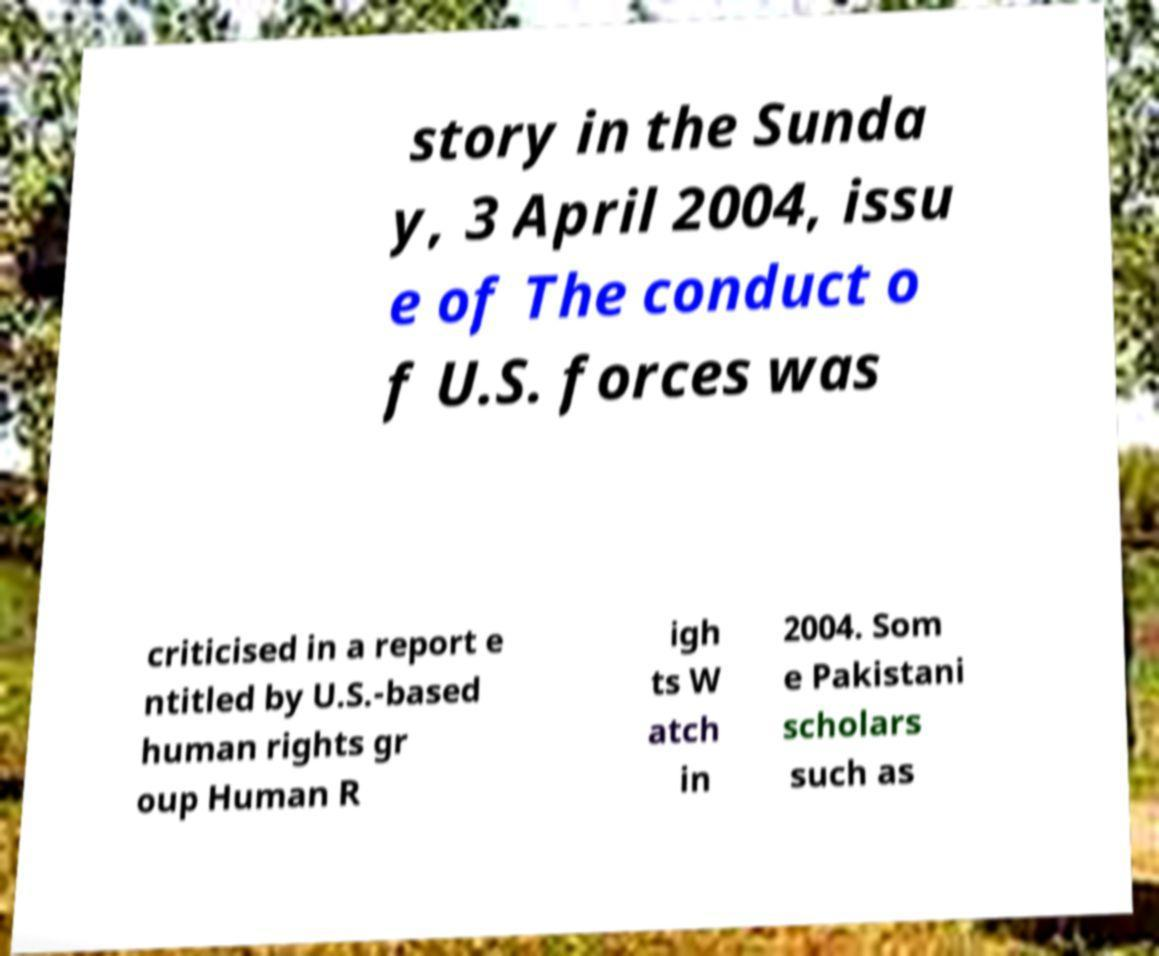There's text embedded in this image that I need extracted. Can you transcribe it verbatim? story in the Sunda y, 3 April 2004, issu e of The conduct o f U.S. forces was criticised in a report e ntitled by U.S.-based human rights gr oup Human R igh ts W atch in 2004. Som e Pakistani scholars such as 